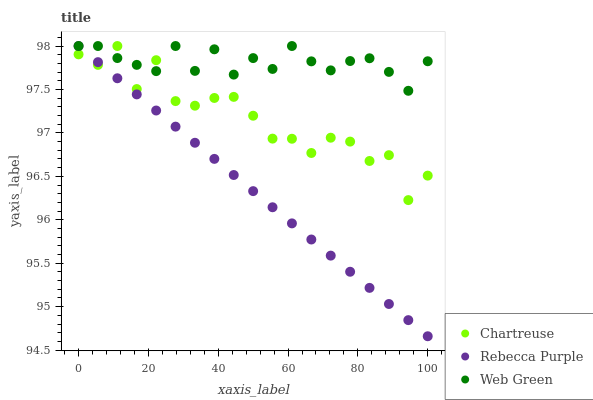Does Rebecca Purple have the minimum area under the curve?
Answer yes or no. Yes. Does Web Green have the maximum area under the curve?
Answer yes or no. Yes. Does Web Green have the minimum area under the curve?
Answer yes or no. No. Does Rebecca Purple have the maximum area under the curve?
Answer yes or no. No. Is Rebecca Purple the smoothest?
Answer yes or no. Yes. Is Chartreuse the roughest?
Answer yes or no. Yes. Is Web Green the smoothest?
Answer yes or no. No. Is Web Green the roughest?
Answer yes or no. No. Does Rebecca Purple have the lowest value?
Answer yes or no. Yes. Does Web Green have the lowest value?
Answer yes or no. No. Does Web Green have the highest value?
Answer yes or no. Yes. Does Chartreuse intersect Web Green?
Answer yes or no. Yes. Is Chartreuse less than Web Green?
Answer yes or no. No. Is Chartreuse greater than Web Green?
Answer yes or no. No. 